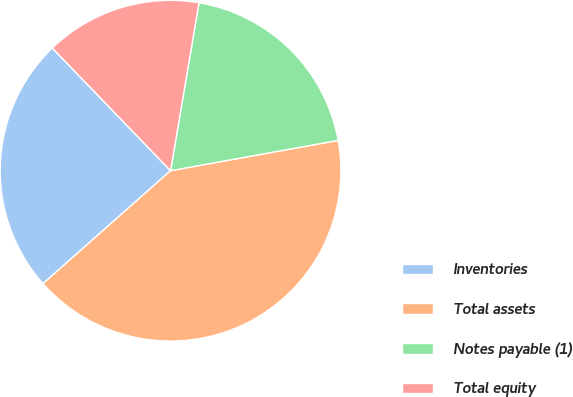Convert chart. <chart><loc_0><loc_0><loc_500><loc_500><pie_chart><fcel>Inventories<fcel>Total assets<fcel>Notes payable (1)<fcel>Total equity<nl><fcel>24.33%<fcel>41.31%<fcel>19.48%<fcel>14.88%<nl></chart> 